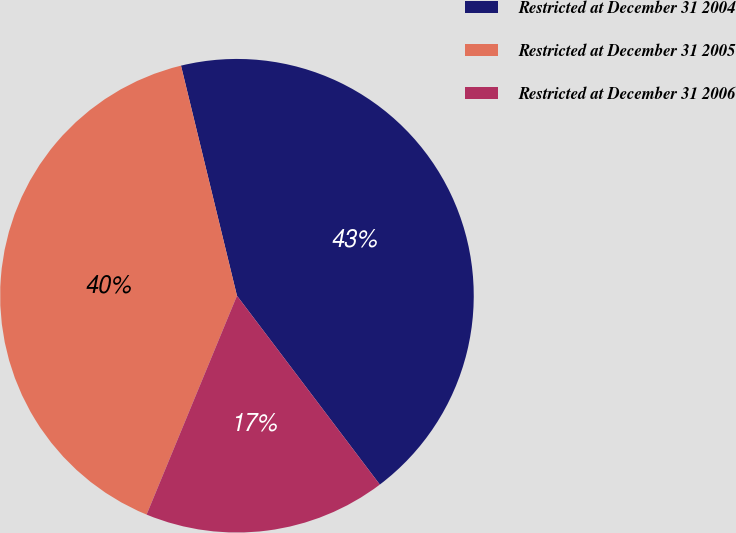Convert chart. <chart><loc_0><loc_0><loc_500><loc_500><pie_chart><fcel>Restricted at December 31 2004<fcel>Restricted at December 31 2005<fcel>Restricted at December 31 2006<nl><fcel>43.49%<fcel>39.97%<fcel>16.54%<nl></chart> 